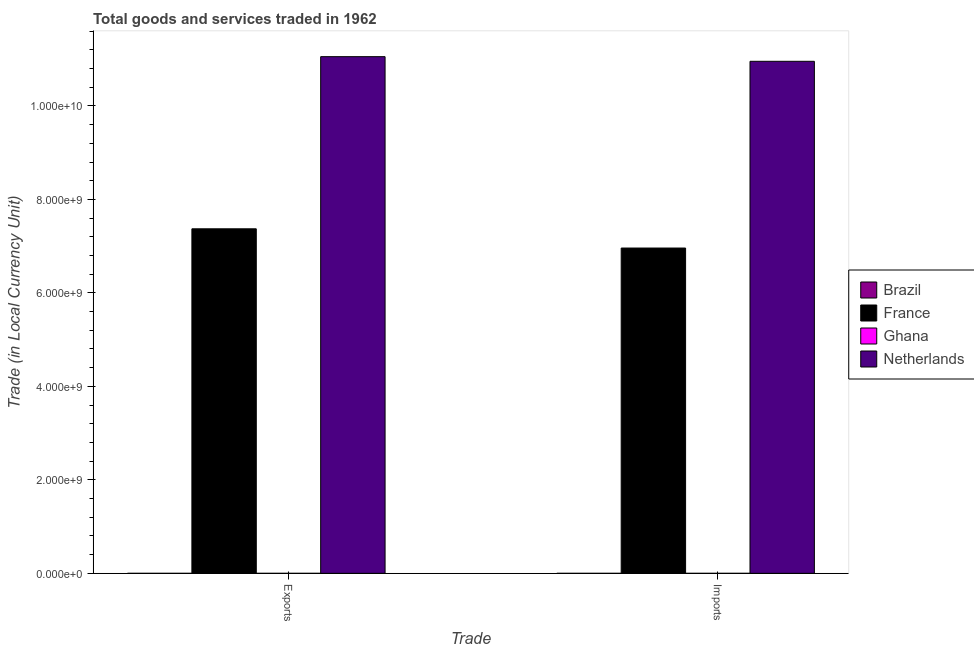How many groups of bars are there?
Offer a terse response. 2. How many bars are there on the 1st tick from the left?
Your response must be concise. 4. How many bars are there on the 2nd tick from the right?
Offer a very short reply. 4. What is the label of the 2nd group of bars from the left?
Keep it short and to the point. Imports. What is the imports of goods and services in Brazil?
Make the answer very short. 0. Across all countries, what is the maximum export of goods and services?
Keep it short and to the point. 1.11e+1. Across all countries, what is the minimum imports of goods and services?
Ensure brevity in your answer.  0. In which country was the imports of goods and services minimum?
Keep it short and to the point. Brazil. What is the total imports of goods and services in the graph?
Offer a terse response. 1.79e+1. What is the difference between the imports of goods and services in France and that in Brazil?
Your answer should be very brief. 6.96e+09. What is the difference between the imports of goods and services in Brazil and the export of goods and services in France?
Make the answer very short. -7.37e+09. What is the average export of goods and services per country?
Your response must be concise. 4.61e+09. What is the difference between the imports of goods and services and export of goods and services in Netherlands?
Provide a succinct answer. -9.94e+07. In how many countries, is the export of goods and services greater than 4800000000 LCU?
Offer a very short reply. 2. What is the ratio of the export of goods and services in Brazil to that in France?
Ensure brevity in your answer.  1.4736950111545272e-14. In how many countries, is the export of goods and services greater than the average export of goods and services taken over all countries?
Your answer should be compact. 2. What does the 1st bar from the right in Exports represents?
Your answer should be compact. Netherlands. How many bars are there?
Ensure brevity in your answer.  8. Are all the bars in the graph horizontal?
Your answer should be compact. No. What is the difference between two consecutive major ticks on the Y-axis?
Your answer should be compact. 2.00e+09. Are the values on the major ticks of Y-axis written in scientific E-notation?
Offer a terse response. Yes. Does the graph contain any zero values?
Provide a succinct answer. No. Does the graph contain grids?
Provide a short and direct response. No. Where does the legend appear in the graph?
Offer a terse response. Center right. How are the legend labels stacked?
Your response must be concise. Vertical. What is the title of the graph?
Provide a succinct answer. Total goods and services traded in 1962. Does "Mali" appear as one of the legend labels in the graph?
Provide a succinct answer. No. What is the label or title of the X-axis?
Your answer should be very brief. Trade. What is the label or title of the Y-axis?
Make the answer very short. Trade (in Local Currency Unit). What is the Trade (in Local Currency Unit) in Brazil in Exports?
Offer a terse response. 0. What is the Trade (in Local Currency Unit) of France in Exports?
Make the answer very short. 7.37e+09. What is the Trade (in Local Currency Unit) of Ghana in Exports?
Provide a short and direct response. 2.39e+04. What is the Trade (in Local Currency Unit) in Netherlands in Exports?
Your answer should be very brief. 1.11e+1. What is the Trade (in Local Currency Unit) in Brazil in Imports?
Ensure brevity in your answer.  0. What is the Trade (in Local Currency Unit) in France in Imports?
Provide a short and direct response. 6.96e+09. What is the Trade (in Local Currency Unit) in Ghana in Imports?
Keep it short and to the point. 2.81e+04. What is the Trade (in Local Currency Unit) of Netherlands in Imports?
Your response must be concise. 1.10e+1. Across all Trade, what is the maximum Trade (in Local Currency Unit) of Brazil?
Your response must be concise. 0. Across all Trade, what is the maximum Trade (in Local Currency Unit) in France?
Ensure brevity in your answer.  7.37e+09. Across all Trade, what is the maximum Trade (in Local Currency Unit) of Ghana?
Give a very brief answer. 2.81e+04. Across all Trade, what is the maximum Trade (in Local Currency Unit) of Netherlands?
Your answer should be very brief. 1.11e+1. Across all Trade, what is the minimum Trade (in Local Currency Unit) of Brazil?
Provide a succinct answer. 0. Across all Trade, what is the minimum Trade (in Local Currency Unit) in France?
Ensure brevity in your answer.  6.96e+09. Across all Trade, what is the minimum Trade (in Local Currency Unit) in Ghana?
Offer a very short reply. 2.39e+04. Across all Trade, what is the minimum Trade (in Local Currency Unit) in Netherlands?
Your response must be concise. 1.10e+1. What is the total Trade (in Local Currency Unit) of France in the graph?
Provide a succinct answer. 1.43e+1. What is the total Trade (in Local Currency Unit) in Ghana in the graph?
Offer a terse response. 5.20e+04. What is the total Trade (in Local Currency Unit) of Netherlands in the graph?
Make the answer very short. 2.20e+1. What is the difference between the Trade (in Local Currency Unit) of France in Exports and that in Imports?
Offer a terse response. 4.11e+08. What is the difference between the Trade (in Local Currency Unit) of Ghana in Exports and that in Imports?
Ensure brevity in your answer.  -4200. What is the difference between the Trade (in Local Currency Unit) in Netherlands in Exports and that in Imports?
Offer a very short reply. 9.94e+07. What is the difference between the Trade (in Local Currency Unit) in Brazil in Exports and the Trade (in Local Currency Unit) in France in Imports?
Provide a short and direct response. -6.96e+09. What is the difference between the Trade (in Local Currency Unit) in Brazil in Exports and the Trade (in Local Currency Unit) in Ghana in Imports?
Make the answer very short. -2.81e+04. What is the difference between the Trade (in Local Currency Unit) of Brazil in Exports and the Trade (in Local Currency Unit) of Netherlands in Imports?
Your answer should be compact. -1.10e+1. What is the difference between the Trade (in Local Currency Unit) in France in Exports and the Trade (in Local Currency Unit) in Ghana in Imports?
Make the answer very short. 7.37e+09. What is the difference between the Trade (in Local Currency Unit) of France in Exports and the Trade (in Local Currency Unit) of Netherlands in Imports?
Your response must be concise. -3.58e+09. What is the difference between the Trade (in Local Currency Unit) of Ghana in Exports and the Trade (in Local Currency Unit) of Netherlands in Imports?
Your response must be concise. -1.10e+1. What is the average Trade (in Local Currency Unit) in Brazil per Trade?
Your response must be concise. 0. What is the average Trade (in Local Currency Unit) in France per Trade?
Provide a succinct answer. 7.17e+09. What is the average Trade (in Local Currency Unit) in Ghana per Trade?
Ensure brevity in your answer.  2.60e+04. What is the average Trade (in Local Currency Unit) of Netherlands per Trade?
Your response must be concise. 1.10e+1. What is the difference between the Trade (in Local Currency Unit) of Brazil and Trade (in Local Currency Unit) of France in Exports?
Provide a short and direct response. -7.37e+09. What is the difference between the Trade (in Local Currency Unit) of Brazil and Trade (in Local Currency Unit) of Ghana in Exports?
Your response must be concise. -2.39e+04. What is the difference between the Trade (in Local Currency Unit) in Brazil and Trade (in Local Currency Unit) in Netherlands in Exports?
Provide a short and direct response. -1.11e+1. What is the difference between the Trade (in Local Currency Unit) in France and Trade (in Local Currency Unit) in Ghana in Exports?
Keep it short and to the point. 7.37e+09. What is the difference between the Trade (in Local Currency Unit) in France and Trade (in Local Currency Unit) in Netherlands in Exports?
Keep it short and to the point. -3.68e+09. What is the difference between the Trade (in Local Currency Unit) in Ghana and Trade (in Local Currency Unit) in Netherlands in Exports?
Offer a terse response. -1.11e+1. What is the difference between the Trade (in Local Currency Unit) in Brazil and Trade (in Local Currency Unit) in France in Imports?
Give a very brief answer. -6.96e+09. What is the difference between the Trade (in Local Currency Unit) in Brazil and Trade (in Local Currency Unit) in Ghana in Imports?
Offer a terse response. -2.81e+04. What is the difference between the Trade (in Local Currency Unit) in Brazil and Trade (in Local Currency Unit) in Netherlands in Imports?
Your answer should be compact. -1.10e+1. What is the difference between the Trade (in Local Currency Unit) in France and Trade (in Local Currency Unit) in Ghana in Imports?
Provide a short and direct response. 6.96e+09. What is the difference between the Trade (in Local Currency Unit) in France and Trade (in Local Currency Unit) in Netherlands in Imports?
Make the answer very short. -3.99e+09. What is the difference between the Trade (in Local Currency Unit) of Ghana and Trade (in Local Currency Unit) of Netherlands in Imports?
Ensure brevity in your answer.  -1.10e+1. What is the ratio of the Trade (in Local Currency Unit) of Brazil in Exports to that in Imports?
Offer a terse response. 0.75. What is the ratio of the Trade (in Local Currency Unit) of France in Exports to that in Imports?
Your response must be concise. 1.06. What is the ratio of the Trade (in Local Currency Unit) in Ghana in Exports to that in Imports?
Your answer should be very brief. 0.85. What is the ratio of the Trade (in Local Currency Unit) in Netherlands in Exports to that in Imports?
Your answer should be compact. 1.01. What is the difference between the highest and the second highest Trade (in Local Currency Unit) in Brazil?
Offer a very short reply. 0. What is the difference between the highest and the second highest Trade (in Local Currency Unit) of France?
Offer a very short reply. 4.11e+08. What is the difference between the highest and the second highest Trade (in Local Currency Unit) of Ghana?
Make the answer very short. 4200. What is the difference between the highest and the second highest Trade (in Local Currency Unit) of Netherlands?
Offer a very short reply. 9.94e+07. What is the difference between the highest and the lowest Trade (in Local Currency Unit) in Brazil?
Your answer should be very brief. 0. What is the difference between the highest and the lowest Trade (in Local Currency Unit) of France?
Ensure brevity in your answer.  4.11e+08. What is the difference between the highest and the lowest Trade (in Local Currency Unit) of Ghana?
Your answer should be compact. 4200. What is the difference between the highest and the lowest Trade (in Local Currency Unit) of Netherlands?
Ensure brevity in your answer.  9.94e+07. 